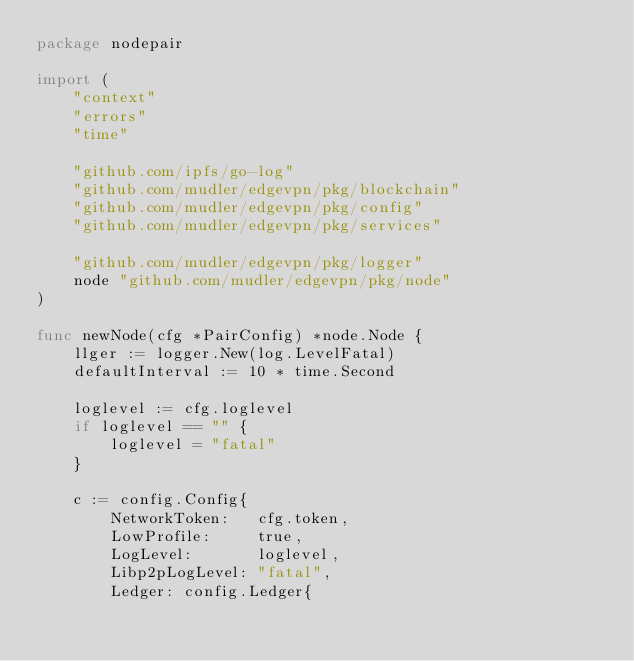Convert code to text. <code><loc_0><loc_0><loc_500><loc_500><_Go_>package nodepair

import (
	"context"
	"errors"
	"time"

	"github.com/ipfs/go-log"
	"github.com/mudler/edgevpn/pkg/blockchain"
	"github.com/mudler/edgevpn/pkg/config"
	"github.com/mudler/edgevpn/pkg/services"

	"github.com/mudler/edgevpn/pkg/logger"
	node "github.com/mudler/edgevpn/pkg/node"
)

func newNode(cfg *PairConfig) *node.Node {
	llger := logger.New(log.LevelFatal)
	defaultInterval := 10 * time.Second

	loglevel := cfg.loglevel
	if loglevel == "" {
		loglevel = "fatal"
	}

	c := config.Config{
		NetworkToken:   cfg.token,
		LowProfile:     true,
		LogLevel:       loglevel,
		Libp2pLogLevel: "fatal",
		Ledger: config.Ledger{</code> 